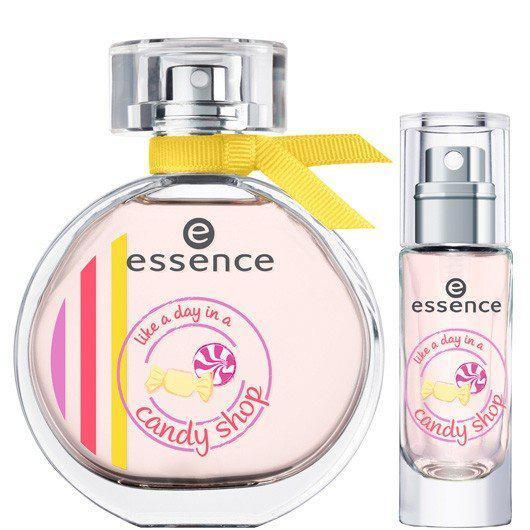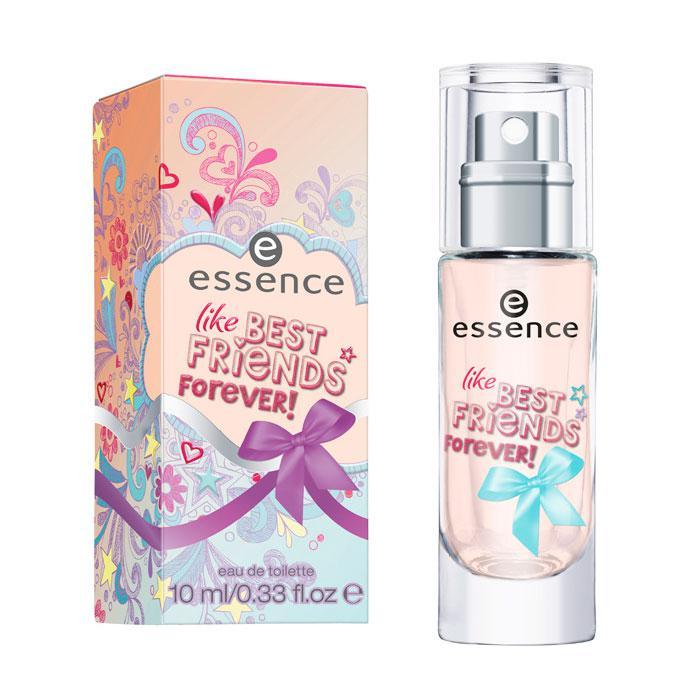The first image is the image on the left, the second image is the image on the right. For the images shown, is this caption "one of the perfume bottles has a ribbon on its neck." true? Answer yes or no. Yes. 